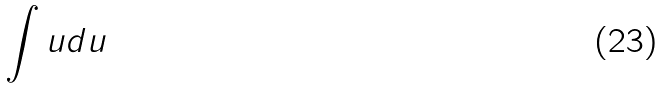Convert formula to latex. <formula><loc_0><loc_0><loc_500><loc_500>\int u d u</formula> 